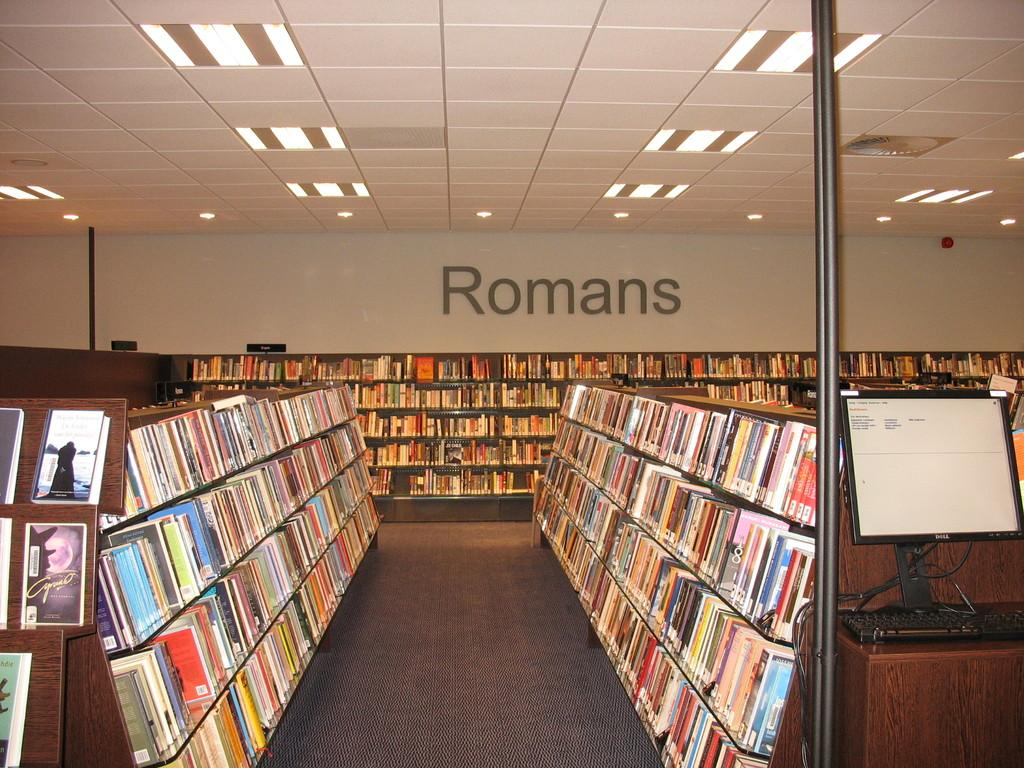<image>
Write a terse but informative summary of the picture. A library full of book shelves says Romans on the wall. 